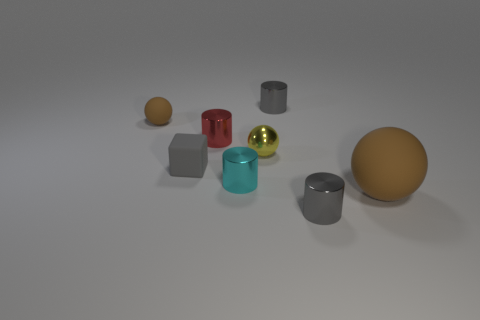Subtract 1 cylinders. How many cylinders are left? 3 Add 1 large green metal spheres. How many objects exist? 9 Subtract all blue cylinders. Subtract all gray spheres. How many cylinders are left? 4 Subtract all blocks. How many objects are left? 7 Subtract all metal things. Subtract all small gray blocks. How many objects are left? 2 Add 3 tiny gray rubber cubes. How many tiny gray rubber cubes are left? 4 Add 3 tiny cyan metallic cylinders. How many tiny cyan metallic cylinders exist? 4 Subtract 1 red cylinders. How many objects are left? 7 